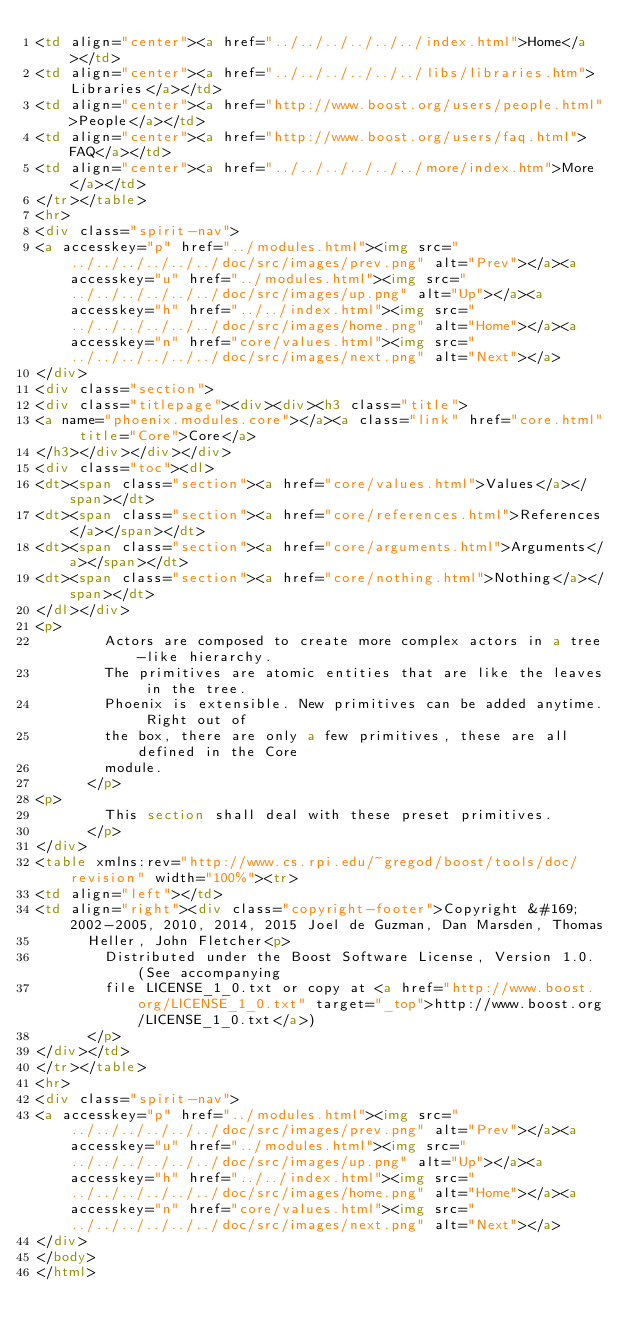Convert code to text. <code><loc_0><loc_0><loc_500><loc_500><_HTML_><td align="center"><a href="../../../../../../index.html">Home</a></td>
<td align="center"><a href="../../../../../../libs/libraries.htm">Libraries</a></td>
<td align="center"><a href="http://www.boost.org/users/people.html">People</a></td>
<td align="center"><a href="http://www.boost.org/users/faq.html">FAQ</a></td>
<td align="center"><a href="../../../../../../more/index.htm">More</a></td>
</tr></table>
<hr>
<div class="spirit-nav">
<a accesskey="p" href="../modules.html"><img src="../../../../../../doc/src/images/prev.png" alt="Prev"></a><a accesskey="u" href="../modules.html"><img src="../../../../../../doc/src/images/up.png" alt="Up"></a><a accesskey="h" href="../../index.html"><img src="../../../../../../doc/src/images/home.png" alt="Home"></a><a accesskey="n" href="core/values.html"><img src="../../../../../../doc/src/images/next.png" alt="Next"></a>
</div>
<div class="section">
<div class="titlepage"><div><div><h3 class="title">
<a name="phoenix.modules.core"></a><a class="link" href="core.html" title="Core">Core</a>
</h3></div></div></div>
<div class="toc"><dl>
<dt><span class="section"><a href="core/values.html">Values</a></span></dt>
<dt><span class="section"><a href="core/references.html">References</a></span></dt>
<dt><span class="section"><a href="core/arguments.html">Arguments</a></span></dt>
<dt><span class="section"><a href="core/nothing.html">Nothing</a></span></dt>
</dl></div>
<p>
        Actors are composed to create more complex actors in a tree-like hierarchy.
        The primitives are atomic entities that are like the leaves in the tree.
        Phoenix is extensible. New primitives can be added anytime. Right out of
        the box, there are only a few primitives, these are all defined in the Core
        module.
      </p>
<p>
        This section shall deal with these preset primitives.
      </p>
</div>
<table xmlns:rev="http://www.cs.rpi.edu/~gregod/boost/tools/doc/revision" width="100%"><tr>
<td align="left"></td>
<td align="right"><div class="copyright-footer">Copyright &#169; 2002-2005, 2010, 2014, 2015 Joel de Guzman, Dan Marsden, Thomas
      Heller, John Fletcher<p>
        Distributed under the Boost Software License, Version 1.0. (See accompanying
        file LICENSE_1_0.txt or copy at <a href="http://www.boost.org/LICENSE_1_0.txt" target="_top">http://www.boost.org/LICENSE_1_0.txt</a>)
      </p>
</div></td>
</tr></table>
<hr>
<div class="spirit-nav">
<a accesskey="p" href="../modules.html"><img src="../../../../../../doc/src/images/prev.png" alt="Prev"></a><a accesskey="u" href="../modules.html"><img src="../../../../../../doc/src/images/up.png" alt="Up"></a><a accesskey="h" href="../../index.html"><img src="../../../../../../doc/src/images/home.png" alt="Home"></a><a accesskey="n" href="core/values.html"><img src="../../../../../../doc/src/images/next.png" alt="Next"></a>
</div>
</body>
</html>
</code> 